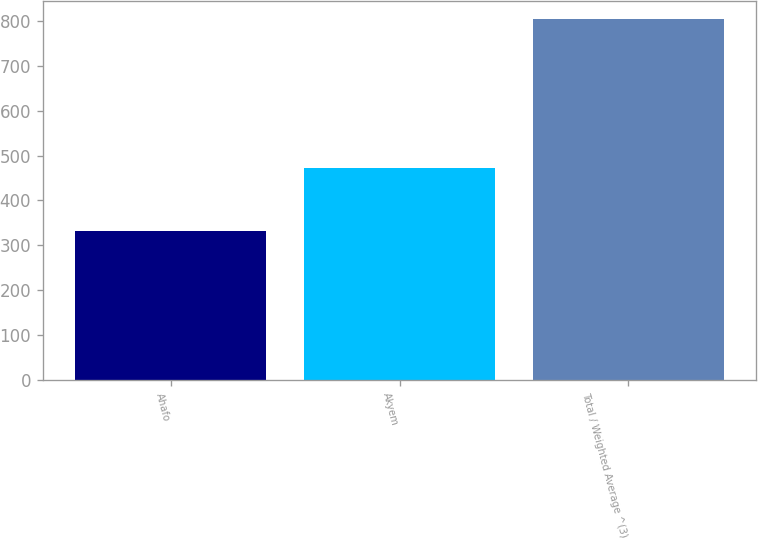Convert chart. <chart><loc_0><loc_0><loc_500><loc_500><bar_chart><fcel>Ahafo<fcel>Akyem<fcel>Total / Weighted Average ^(3)<nl><fcel>332<fcel>473<fcel>805<nl></chart> 